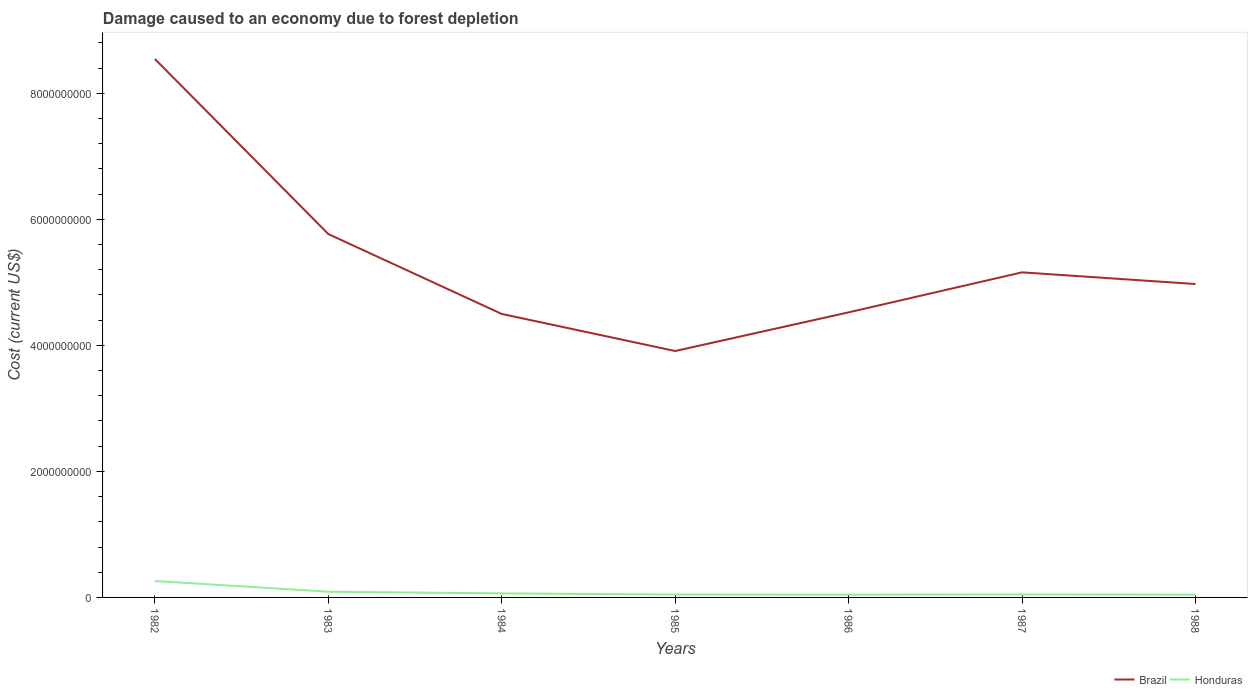How many different coloured lines are there?
Make the answer very short. 2. Is the number of lines equal to the number of legend labels?
Provide a short and direct response. Yes. Across all years, what is the maximum cost of damage caused due to forest depletion in Brazil?
Provide a succinct answer. 3.91e+09. What is the total cost of damage caused due to forest depletion in Honduras in the graph?
Make the answer very short. -1.77e+06. What is the difference between the highest and the second highest cost of damage caused due to forest depletion in Honduras?
Make the answer very short. 2.17e+08. What is the difference between the highest and the lowest cost of damage caused due to forest depletion in Brazil?
Your answer should be compact. 2. Is the cost of damage caused due to forest depletion in Brazil strictly greater than the cost of damage caused due to forest depletion in Honduras over the years?
Your response must be concise. No. Are the values on the major ticks of Y-axis written in scientific E-notation?
Ensure brevity in your answer.  No. Does the graph contain grids?
Offer a very short reply. No. How are the legend labels stacked?
Give a very brief answer. Horizontal. What is the title of the graph?
Provide a short and direct response. Damage caused to an economy due to forest depletion. Does "Caribbean small states" appear as one of the legend labels in the graph?
Make the answer very short. No. What is the label or title of the Y-axis?
Your answer should be very brief. Cost (current US$). What is the Cost (current US$) of Brazil in 1982?
Your answer should be very brief. 8.54e+09. What is the Cost (current US$) in Honduras in 1982?
Your response must be concise. 2.61e+08. What is the Cost (current US$) in Brazil in 1983?
Ensure brevity in your answer.  5.77e+09. What is the Cost (current US$) in Honduras in 1983?
Provide a short and direct response. 9.09e+07. What is the Cost (current US$) of Brazil in 1984?
Your answer should be compact. 4.50e+09. What is the Cost (current US$) of Honduras in 1984?
Ensure brevity in your answer.  6.46e+07. What is the Cost (current US$) of Brazil in 1985?
Give a very brief answer. 3.91e+09. What is the Cost (current US$) in Honduras in 1985?
Ensure brevity in your answer.  4.52e+07. What is the Cost (current US$) of Brazil in 1986?
Ensure brevity in your answer.  4.52e+09. What is the Cost (current US$) of Honduras in 1986?
Your response must be concise. 4.38e+07. What is the Cost (current US$) in Brazil in 1987?
Ensure brevity in your answer.  5.16e+09. What is the Cost (current US$) in Honduras in 1987?
Your answer should be very brief. 4.70e+07. What is the Cost (current US$) of Brazil in 1988?
Your answer should be compact. 4.97e+09. What is the Cost (current US$) of Honduras in 1988?
Your answer should be compact. 4.37e+07. Across all years, what is the maximum Cost (current US$) of Brazil?
Ensure brevity in your answer.  8.54e+09. Across all years, what is the maximum Cost (current US$) in Honduras?
Give a very brief answer. 2.61e+08. Across all years, what is the minimum Cost (current US$) of Brazil?
Your response must be concise. 3.91e+09. Across all years, what is the minimum Cost (current US$) in Honduras?
Provide a succinct answer. 4.37e+07. What is the total Cost (current US$) of Brazil in the graph?
Give a very brief answer. 3.74e+1. What is the total Cost (current US$) of Honduras in the graph?
Keep it short and to the point. 5.96e+08. What is the difference between the Cost (current US$) in Brazil in 1982 and that in 1983?
Offer a terse response. 2.78e+09. What is the difference between the Cost (current US$) of Honduras in 1982 and that in 1983?
Give a very brief answer. 1.70e+08. What is the difference between the Cost (current US$) of Brazil in 1982 and that in 1984?
Make the answer very short. 4.05e+09. What is the difference between the Cost (current US$) in Honduras in 1982 and that in 1984?
Your response must be concise. 1.96e+08. What is the difference between the Cost (current US$) of Brazil in 1982 and that in 1985?
Give a very brief answer. 4.63e+09. What is the difference between the Cost (current US$) of Honduras in 1982 and that in 1985?
Your answer should be compact. 2.15e+08. What is the difference between the Cost (current US$) in Brazil in 1982 and that in 1986?
Your response must be concise. 4.02e+09. What is the difference between the Cost (current US$) in Honduras in 1982 and that in 1986?
Your answer should be compact. 2.17e+08. What is the difference between the Cost (current US$) in Brazil in 1982 and that in 1987?
Your response must be concise. 3.39e+09. What is the difference between the Cost (current US$) in Honduras in 1982 and that in 1987?
Provide a succinct answer. 2.14e+08. What is the difference between the Cost (current US$) in Brazil in 1982 and that in 1988?
Your response must be concise. 3.57e+09. What is the difference between the Cost (current US$) in Honduras in 1982 and that in 1988?
Provide a short and direct response. 2.17e+08. What is the difference between the Cost (current US$) in Brazil in 1983 and that in 1984?
Offer a very short reply. 1.27e+09. What is the difference between the Cost (current US$) in Honduras in 1983 and that in 1984?
Make the answer very short. 2.63e+07. What is the difference between the Cost (current US$) in Brazil in 1983 and that in 1985?
Offer a terse response. 1.86e+09. What is the difference between the Cost (current US$) of Honduras in 1983 and that in 1985?
Ensure brevity in your answer.  4.57e+07. What is the difference between the Cost (current US$) in Brazil in 1983 and that in 1986?
Give a very brief answer. 1.24e+09. What is the difference between the Cost (current US$) in Honduras in 1983 and that in 1986?
Make the answer very short. 4.71e+07. What is the difference between the Cost (current US$) in Brazil in 1983 and that in 1987?
Make the answer very short. 6.07e+08. What is the difference between the Cost (current US$) in Honduras in 1983 and that in 1987?
Your answer should be very brief. 4.39e+07. What is the difference between the Cost (current US$) in Brazil in 1983 and that in 1988?
Give a very brief answer. 7.93e+08. What is the difference between the Cost (current US$) of Honduras in 1983 and that in 1988?
Keep it short and to the point. 4.72e+07. What is the difference between the Cost (current US$) in Brazil in 1984 and that in 1985?
Give a very brief answer. 5.88e+08. What is the difference between the Cost (current US$) in Honduras in 1984 and that in 1985?
Give a very brief answer. 1.94e+07. What is the difference between the Cost (current US$) of Brazil in 1984 and that in 1986?
Provide a short and direct response. -2.55e+07. What is the difference between the Cost (current US$) in Honduras in 1984 and that in 1986?
Provide a succinct answer. 2.08e+07. What is the difference between the Cost (current US$) of Brazil in 1984 and that in 1987?
Your answer should be very brief. -6.60e+08. What is the difference between the Cost (current US$) of Honduras in 1984 and that in 1987?
Keep it short and to the point. 1.76e+07. What is the difference between the Cost (current US$) in Brazil in 1984 and that in 1988?
Offer a very short reply. -4.75e+08. What is the difference between the Cost (current US$) in Honduras in 1984 and that in 1988?
Offer a terse response. 2.09e+07. What is the difference between the Cost (current US$) in Brazil in 1985 and that in 1986?
Make the answer very short. -6.14e+08. What is the difference between the Cost (current US$) in Honduras in 1985 and that in 1986?
Your answer should be compact. 1.40e+06. What is the difference between the Cost (current US$) in Brazil in 1985 and that in 1987?
Make the answer very short. -1.25e+09. What is the difference between the Cost (current US$) of Honduras in 1985 and that in 1987?
Your answer should be very brief. -1.77e+06. What is the difference between the Cost (current US$) in Brazil in 1985 and that in 1988?
Provide a short and direct response. -1.06e+09. What is the difference between the Cost (current US$) in Honduras in 1985 and that in 1988?
Offer a terse response. 1.51e+06. What is the difference between the Cost (current US$) in Brazil in 1986 and that in 1987?
Your response must be concise. -6.35e+08. What is the difference between the Cost (current US$) in Honduras in 1986 and that in 1987?
Keep it short and to the point. -3.17e+06. What is the difference between the Cost (current US$) of Brazil in 1986 and that in 1988?
Your response must be concise. -4.49e+08. What is the difference between the Cost (current US$) in Honduras in 1986 and that in 1988?
Give a very brief answer. 1.13e+05. What is the difference between the Cost (current US$) of Brazil in 1987 and that in 1988?
Ensure brevity in your answer.  1.85e+08. What is the difference between the Cost (current US$) of Honduras in 1987 and that in 1988?
Provide a short and direct response. 3.28e+06. What is the difference between the Cost (current US$) in Brazil in 1982 and the Cost (current US$) in Honduras in 1983?
Give a very brief answer. 8.45e+09. What is the difference between the Cost (current US$) in Brazil in 1982 and the Cost (current US$) in Honduras in 1984?
Offer a very short reply. 8.48e+09. What is the difference between the Cost (current US$) of Brazil in 1982 and the Cost (current US$) of Honduras in 1985?
Keep it short and to the point. 8.50e+09. What is the difference between the Cost (current US$) of Brazil in 1982 and the Cost (current US$) of Honduras in 1986?
Your answer should be very brief. 8.50e+09. What is the difference between the Cost (current US$) in Brazil in 1982 and the Cost (current US$) in Honduras in 1987?
Your answer should be very brief. 8.50e+09. What is the difference between the Cost (current US$) of Brazil in 1982 and the Cost (current US$) of Honduras in 1988?
Your answer should be compact. 8.50e+09. What is the difference between the Cost (current US$) of Brazil in 1983 and the Cost (current US$) of Honduras in 1984?
Provide a succinct answer. 5.70e+09. What is the difference between the Cost (current US$) in Brazil in 1983 and the Cost (current US$) in Honduras in 1985?
Your response must be concise. 5.72e+09. What is the difference between the Cost (current US$) in Brazil in 1983 and the Cost (current US$) in Honduras in 1986?
Keep it short and to the point. 5.72e+09. What is the difference between the Cost (current US$) in Brazil in 1983 and the Cost (current US$) in Honduras in 1987?
Ensure brevity in your answer.  5.72e+09. What is the difference between the Cost (current US$) of Brazil in 1983 and the Cost (current US$) of Honduras in 1988?
Ensure brevity in your answer.  5.72e+09. What is the difference between the Cost (current US$) in Brazil in 1984 and the Cost (current US$) in Honduras in 1985?
Ensure brevity in your answer.  4.45e+09. What is the difference between the Cost (current US$) in Brazil in 1984 and the Cost (current US$) in Honduras in 1986?
Keep it short and to the point. 4.45e+09. What is the difference between the Cost (current US$) of Brazil in 1984 and the Cost (current US$) of Honduras in 1987?
Your answer should be very brief. 4.45e+09. What is the difference between the Cost (current US$) of Brazil in 1984 and the Cost (current US$) of Honduras in 1988?
Offer a terse response. 4.45e+09. What is the difference between the Cost (current US$) of Brazil in 1985 and the Cost (current US$) of Honduras in 1986?
Provide a succinct answer. 3.87e+09. What is the difference between the Cost (current US$) of Brazil in 1985 and the Cost (current US$) of Honduras in 1987?
Ensure brevity in your answer.  3.86e+09. What is the difference between the Cost (current US$) in Brazil in 1985 and the Cost (current US$) in Honduras in 1988?
Ensure brevity in your answer.  3.87e+09. What is the difference between the Cost (current US$) of Brazil in 1986 and the Cost (current US$) of Honduras in 1987?
Your response must be concise. 4.48e+09. What is the difference between the Cost (current US$) in Brazil in 1986 and the Cost (current US$) in Honduras in 1988?
Offer a very short reply. 4.48e+09. What is the difference between the Cost (current US$) of Brazil in 1987 and the Cost (current US$) of Honduras in 1988?
Your answer should be very brief. 5.12e+09. What is the average Cost (current US$) in Brazil per year?
Offer a terse response. 5.34e+09. What is the average Cost (current US$) in Honduras per year?
Your answer should be compact. 8.51e+07. In the year 1982, what is the difference between the Cost (current US$) of Brazil and Cost (current US$) of Honduras?
Your response must be concise. 8.28e+09. In the year 1983, what is the difference between the Cost (current US$) in Brazil and Cost (current US$) in Honduras?
Your answer should be compact. 5.68e+09. In the year 1984, what is the difference between the Cost (current US$) of Brazil and Cost (current US$) of Honduras?
Your response must be concise. 4.43e+09. In the year 1985, what is the difference between the Cost (current US$) of Brazil and Cost (current US$) of Honduras?
Your response must be concise. 3.87e+09. In the year 1986, what is the difference between the Cost (current US$) of Brazil and Cost (current US$) of Honduras?
Offer a terse response. 4.48e+09. In the year 1987, what is the difference between the Cost (current US$) in Brazil and Cost (current US$) in Honduras?
Your response must be concise. 5.11e+09. In the year 1988, what is the difference between the Cost (current US$) in Brazil and Cost (current US$) in Honduras?
Offer a terse response. 4.93e+09. What is the ratio of the Cost (current US$) in Brazil in 1982 to that in 1983?
Offer a very short reply. 1.48. What is the ratio of the Cost (current US$) of Honduras in 1982 to that in 1983?
Your answer should be compact. 2.87. What is the ratio of the Cost (current US$) of Brazil in 1982 to that in 1984?
Provide a short and direct response. 1.9. What is the ratio of the Cost (current US$) in Honduras in 1982 to that in 1984?
Your answer should be compact. 4.04. What is the ratio of the Cost (current US$) of Brazil in 1982 to that in 1985?
Provide a short and direct response. 2.18. What is the ratio of the Cost (current US$) in Honduras in 1982 to that in 1985?
Your answer should be very brief. 5.76. What is the ratio of the Cost (current US$) in Brazil in 1982 to that in 1986?
Offer a very short reply. 1.89. What is the ratio of the Cost (current US$) in Honduras in 1982 to that in 1986?
Offer a very short reply. 5.95. What is the ratio of the Cost (current US$) in Brazil in 1982 to that in 1987?
Offer a terse response. 1.66. What is the ratio of the Cost (current US$) in Honduras in 1982 to that in 1987?
Your answer should be very brief. 5.55. What is the ratio of the Cost (current US$) of Brazil in 1982 to that in 1988?
Provide a succinct answer. 1.72. What is the ratio of the Cost (current US$) of Honduras in 1982 to that in 1988?
Offer a very short reply. 5.96. What is the ratio of the Cost (current US$) of Brazil in 1983 to that in 1984?
Provide a short and direct response. 1.28. What is the ratio of the Cost (current US$) in Honduras in 1983 to that in 1984?
Offer a terse response. 1.41. What is the ratio of the Cost (current US$) in Brazil in 1983 to that in 1985?
Provide a succinct answer. 1.47. What is the ratio of the Cost (current US$) of Honduras in 1983 to that in 1985?
Your answer should be very brief. 2.01. What is the ratio of the Cost (current US$) in Brazil in 1983 to that in 1986?
Give a very brief answer. 1.27. What is the ratio of the Cost (current US$) of Honduras in 1983 to that in 1986?
Provide a succinct answer. 2.07. What is the ratio of the Cost (current US$) in Brazil in 1983 to that in 1987?
Your answer should be very brief. 1.12. What is the ratio of the Cost (current US$) in Honduras in 1983 to that in 1987?
Keep it short and to the point. 1.93. What is the ratio of the Cost (current US$) of Brazil in 1983 to that in 1988?
Provide a short and direct response. 1.16. What is the ratio of the Cost (current US$) in Honduras in 1983 to that in 1988?
Keep it short and to the point. 2.08. What is the ratio of the Cost (current US$) in Brazil in 1984 to that in 1985?
Your response must be concise. 1.15. What is the ratio of the Cost (current US$) in Honduras in 1984 to that in 1985?
Offer a very short reply. 1.43. What is the ratio of the Cost (current US$) of Brazil in 1984 to that in 1986?
Your response must be concise. 0.99. What is the ratio of the Cost (current US$) in Honduras in 1984 to that in 1986?
Offer a very short reply. 1.47. What is the ratio of the Cost (current US$) of Brazil in 1984 to that in 1987?
Provide a succinct answer. 0.87. What is the ratio of the Cost (current US$) of Honduras in 1984 to that in 1987?
Make the answer very short. 1.37. What is the ratio of the Cost (current US$) in Brazil in 1984 to that in 1988?
Give a very brief answer. 0.9. What is the ratio of the Cost (current US$) of Honduras in 1984 to that in 1988?
Provide a succinct answer. 1.48. What is the ratio of the Cost (current US$) in Brazil in 1985 to that in 1986?
Offer a terse response. 0.86. What is the ratio of the Cost (current US$) of Honduras in 1985 to that in 1986?
Keep it short and to the point. 1.03. What is the ratio of the Cost (current US$) of Brazil in 1985 to that in 1987?
Offer a terse response. 0.76. What is the ratio of the Cost (current US$) in Honduras in 1985 to that in 1987?
Your answer should be very brief. 0.96. What is the ratio of the Cost (current US$) in Brazil in 1985 to that in 1988?
Provide a succinct answer. 0.79. What is the ratio of the Cost (current US$) of Honduras in 1985 to that in 1988?
Make the answer very short. 1.03. What is the ratio of the Cost (current US$) in Brazil in 1986 to that in 1987?
Your answer should be compact. 0.88. What is the ratio of the Cost (current US$) in Honduras in 1986 to that in 1987?
Your answer should be compact. 0.93. What is the ratio of the Cost (current US$) of Brazil in 1986 to that in 1988?
Your answer should be compact. 0.91. What is the ratio of the Cost (current US$) of Honduras in 1986 to that in 1988?
Make the answer very short. 1. What is the ratio of the Cost (current US$) of Brazil in 1987 to that in 1988?
Ensure brevity in your answer.  1.04. What is the ratio of the Cost (current US$) of Honduras in 1987 to that in 1988?
Provide a short and direct response. 1.08. What is the difference between the highest and the second highest Cost (current US$) in Brazil?
Give a very brief answer. 2.78e+09. What is the difference between the highest and the second highest Cost (current US$) in Honduras?
Your answer should be very brief. 1.70e+08. What is the difference between the highest and the lowest Cost (current US$) of Brazil?
Your answer should be compact. 4.63e+09. What is the difference between the highest and the lowest Cost (current US$) of Honduras?
Make the answer very short. 2.17e+08. 